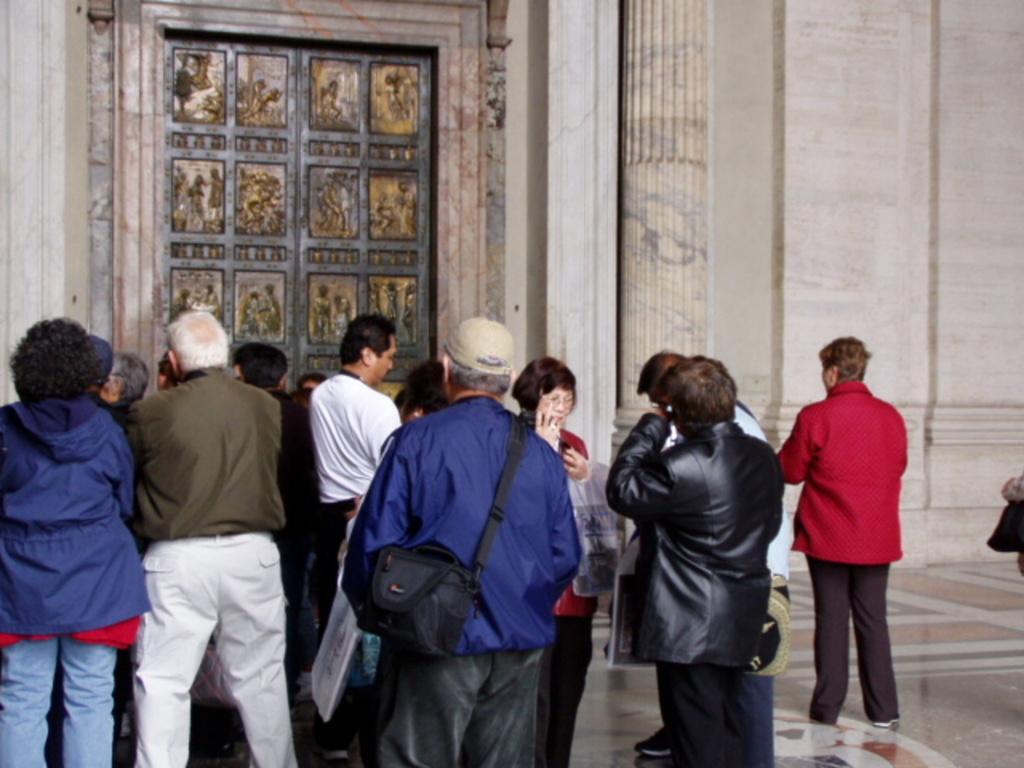Could you give a brief overview of what you see in this image? In this image I can see people standing. There is a door at the back. 